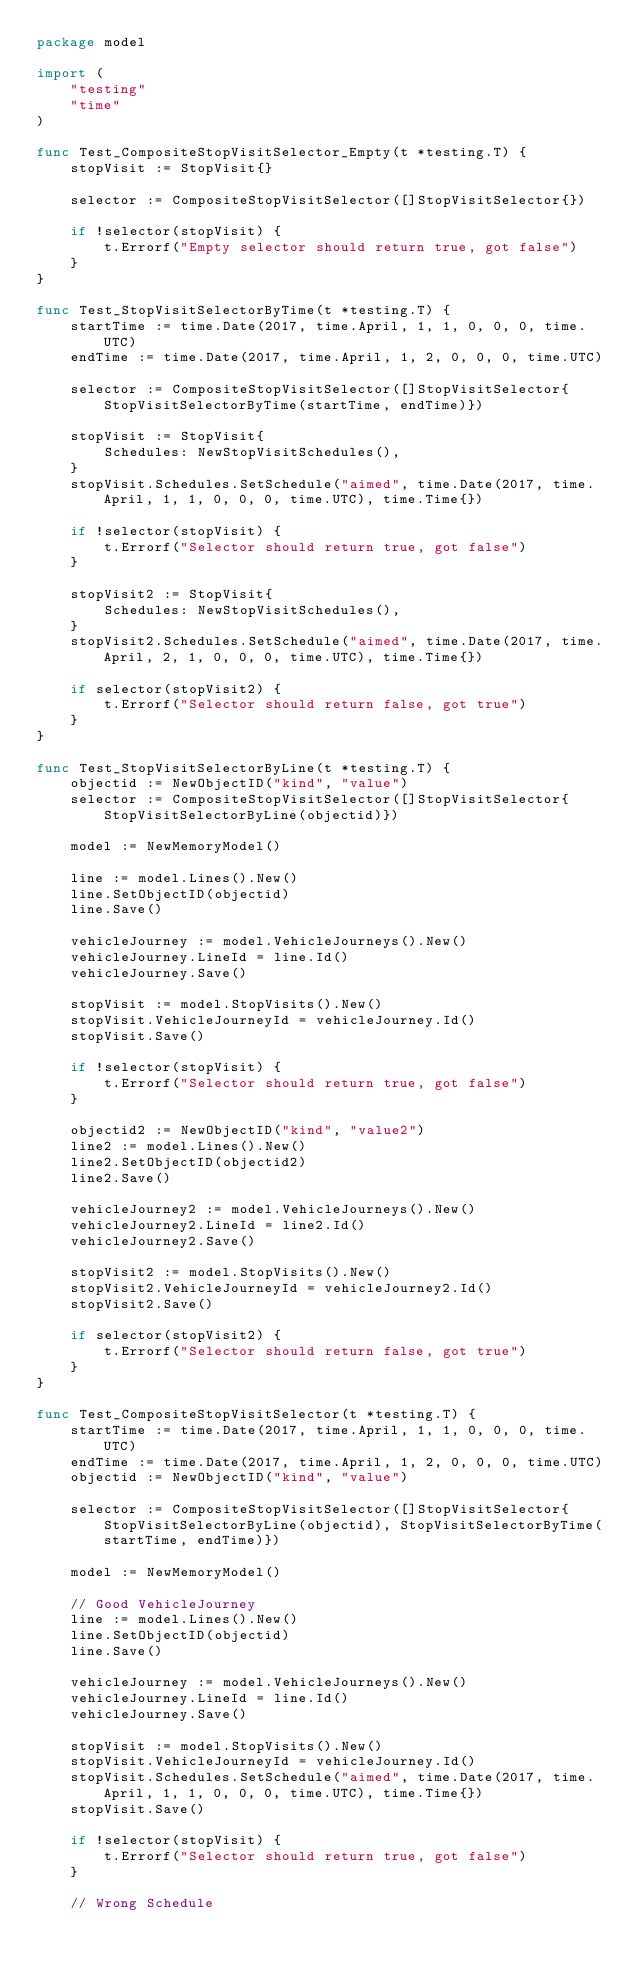Convert code to text. <code><loc_0><loc_0><loc_500><loc_500><_Go_>package model

import (
	"testing"
	"time"
)

func Test_CompositeStopVisitSelector_Empty(t *testing.T) {
	stopVisit := StopVisit{}

	selector := CompositeStopVisitSelector([]StopVisitSelector{})

	if !selector(stopVisit) {
		t.Errorf("Empty selector should return true, got false")
	}
}

func Test_StopVisitSelectorByTime(t *testing.T) {
	startTime := time.Date(2017, time.April, 1, 1, 0, 0, 0, time.UTC)
	endTime := time.Date(2017, time.April, 1, 2, 0, 0, 0, time.UTC)

	selector := CompositeStopVisitSelector([]StopVisitSelector{StopVisitSelectorByTime(startTime, endTime)})

	stopVisit := StopVisit{
		Schedules: NewStopVisitSchedules(),
	}
	stopVisit.Schedules.SetSchedule("aimed", time.Date(2017, time.April, 1, 1, 0, 0, 0, time.UTC), time.Time{})

	if !selector(stopVisit) {
		t.Errorf("Selector should return true, got false")
	}

	stopVisit2 := StopVisit{
		Schedules: NewStopVisitSchedules(),
	}
	stopVisit2.Schedules.SetSchedule("aimed", time.Date(2017, time.April, 2, 1, 0, 0, 0, time.UTC), time.Time{})

	if selector(stopVisit2) {
		t.Errorf("Selector should return false, got true")
	}
}

func Test_StopVisitSelectorByLine(t *testing.T) {
	objectid := NewObjectID("kind", "value")
	selector := CompositeStopVisitSelector([]StopVisitSelector{StopVisitSelectorByLine(objectid)})

	model := NewMemoryModel()

	line := model.Lines().New()
	line.SetObjectID(objectid)
	line.Save()

	vehicleJourney := model.VehicleJourneys().New()
	vehicleJourney.LineId = line.Id()
	vehicleJourney.Save()

	stopVisit := model.StopVisits().New()
	stopVisit.VehicleJourneyId = vehicleJourney.Id()
	stopVisit.Save()

	if !selector(stopVisit) {
		t.Errorf("Selector should return true, got false")
	}

	objectid2 := NewObjectID("kind", "value2")
	line2 := model.Lines().New()
	line2.SetObjectID(objectid2)
	line2.Save()

	vehicleJourney2 := model.VehicleJourneys().New()
	vehicleJourney2.LineId = line2.Id()
	vehicleJourney2.Save()

	stopVisit2 := model.StopVisits().New()
	stopVisit2.VehicleJourneyId = vehicleJourney2.Id()
	stopVisit2.Save()

	if selector(stopVisit2) {
		t.Errorf("Selector should return false, got true")
	}
}

func Test_CompositeStopVisitSelector(t *testing.T) {
	startTime := time.Date(2017, time.April, 1, 1, 0, 0, 0, time.UTC)
	endTime := time.Date(2017, time.April, 1, 2, 0, 0, 0, time.UTC)
	objectid := NewObjectID("kind", "value")

	selector := CompositeStopVisitSelector([]StopVisitSelector{StopVisitSelectorByLine(objectid), StopVisitSelectorByTime(startTime, endTime)})

	model := NewMemoryModel()

	// Good VehicleJourney
	line := model.Lines().New()
	line.SetObjectID(objectid)
	line.Save()

	vehicleJourney := model.VehicleJourneys().New()
	vehicleJourney.LineId = line.Id()
	vehicleJourney.Save()

	stopVisit := model.StopVisits().New()
	stopVisit.VehicleJourneyId = vehicleJourney.Id()
	stopVisit.Schedules.SetSchedule("aimed", time.Date(2017, time.April, 1, 1, 0, 0, 0, time.UTC), time.Time{})
	stopVisit.Save()

	if !selector(stopVisit) {
		t.Errorf("Selector should return true, got false")
	}

	// Wrong Schedule</code> 